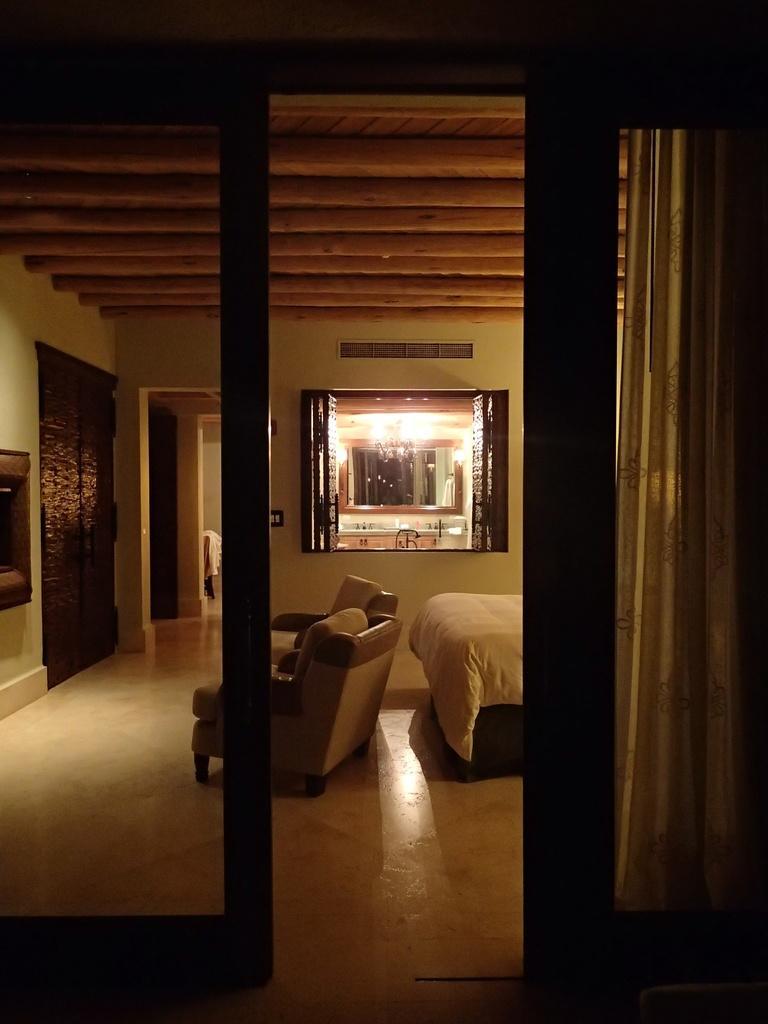Could you give a brief overview of what you see in this image? In this image on the right side, I can see a curtain. I can see a bed. I can see the sofa. In the background, I can see a window. 